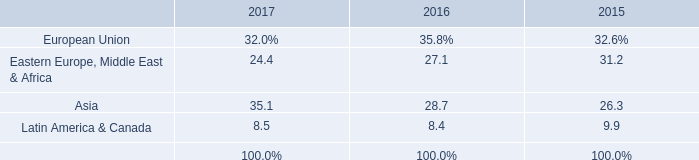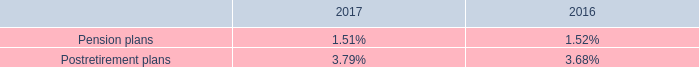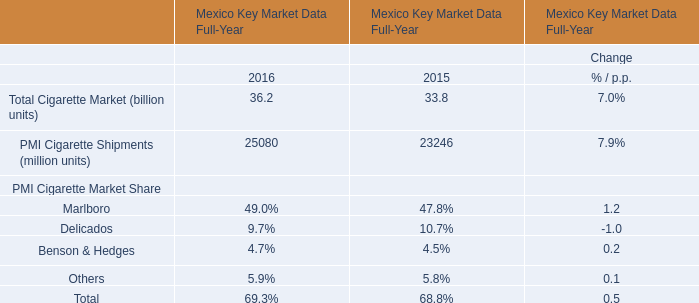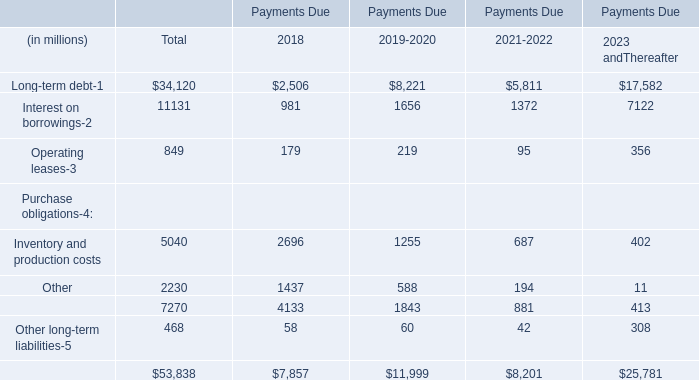what is the percentage change in the pre-tax pension and postretirement expense from 2017 to 2018? 
Computations: ((164 - 199) / 199)
Answer: -0.17588. 